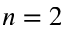<formula> <loc_0><loc_0><loc_500><loc_500>n = 2</formula> 